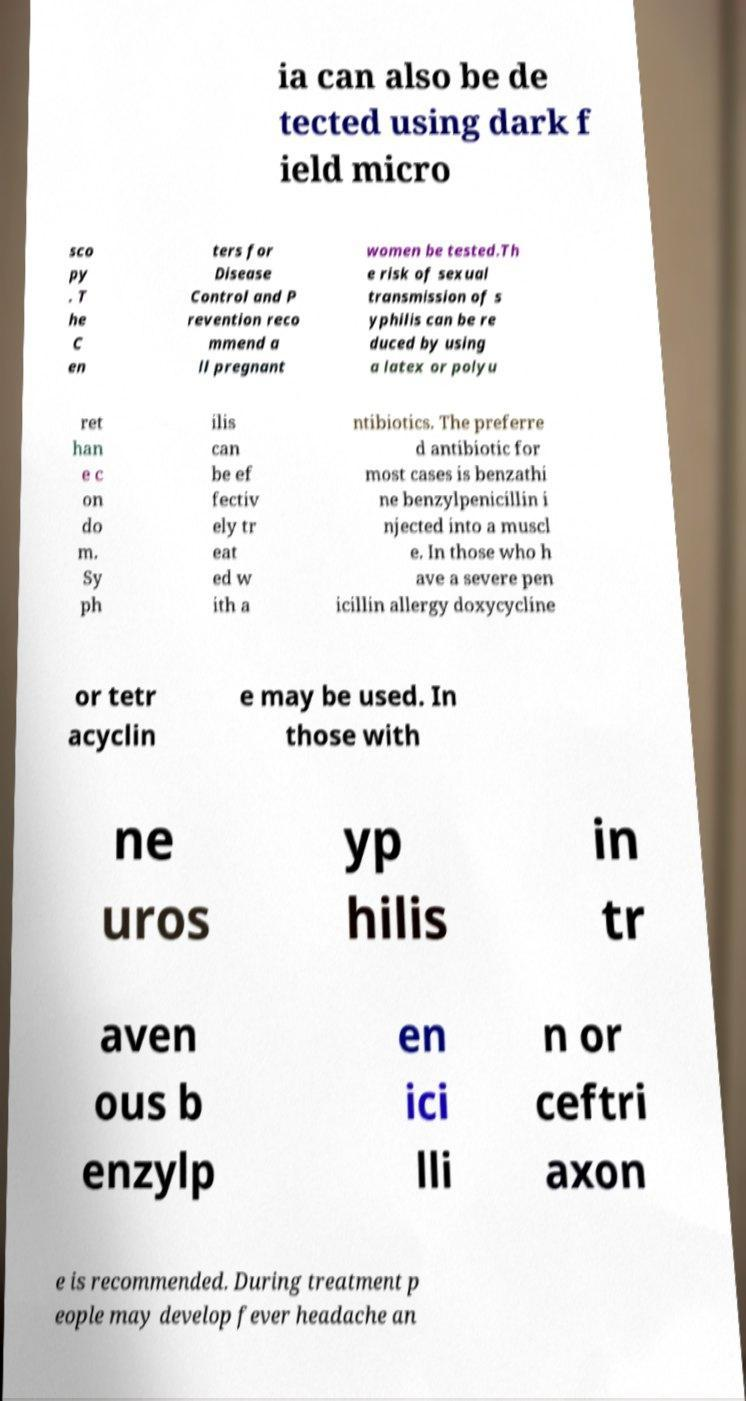Please read and relay the text visible in this image. What does it say? ia can also be de tected using dark f ield micro sco py . T he C en ters for Disease Control and P revention reco mmend a ll pregnant women be tested.Th e risk of sexual transmission of s yphilis can be re duced by using a latex or polyu ret han e c on do m. Sy ph ilis can be ef fectiv ely tr eat ed w ith a ntibiotics. The preferre d antibiotic for most cases is benzathi ne benzylpenicillin i njected into a muscl e. In those who h ave a severe pen icillin allergy doxycycline or tetr acyclin e may be used. In those with ne uros yp hilis in tr aven ous b enzylp en ici lli n or ceftri axon e is recommended. During treatment p eople may develop fever headache an 